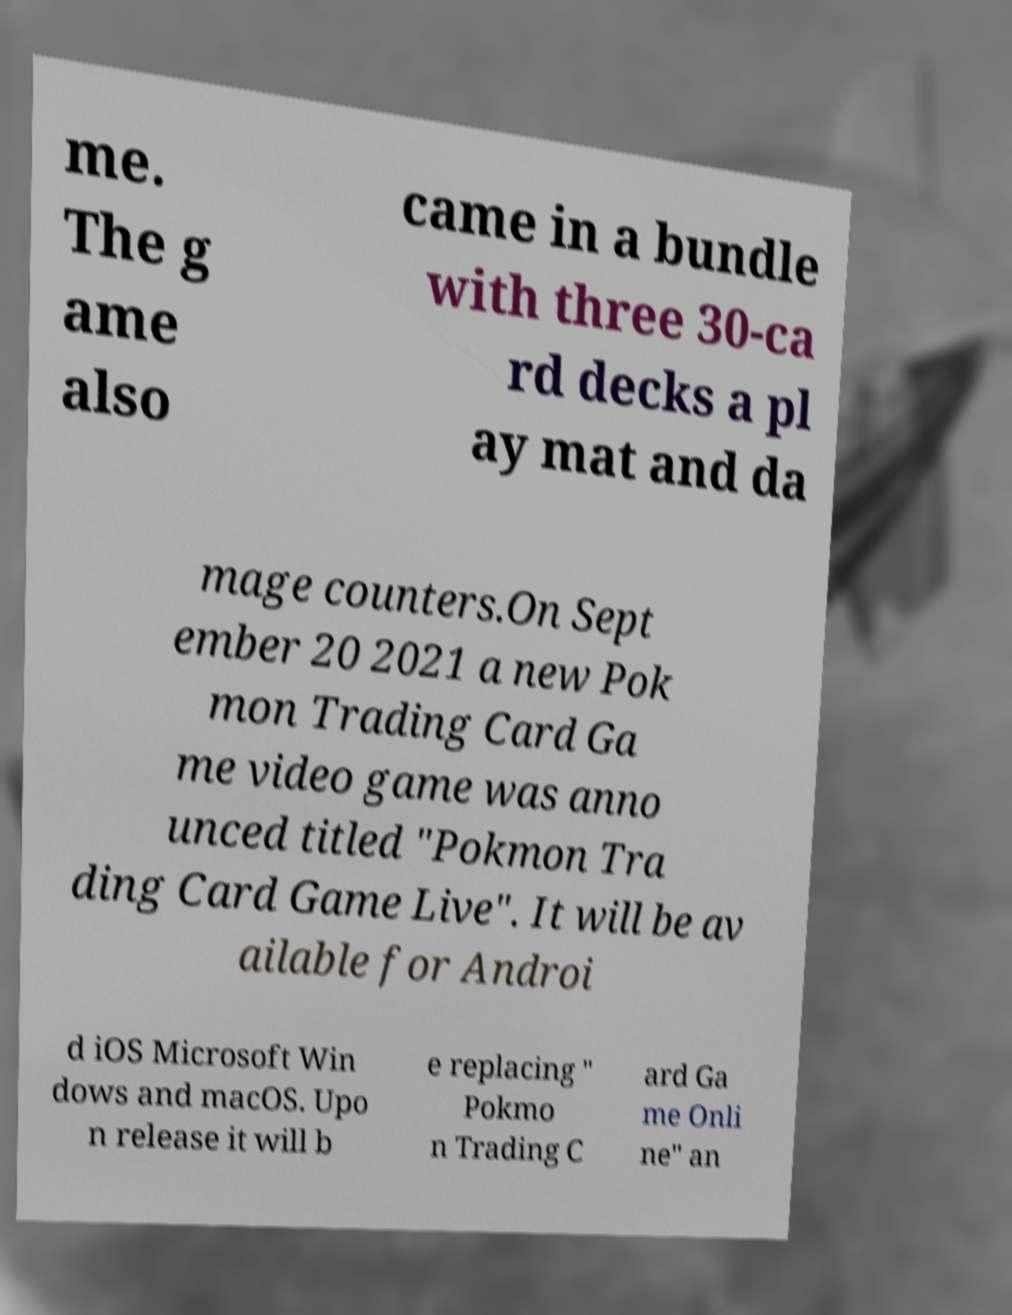Please identify and transcribe the text found in this image. me. The g ame also came in a bundle with three 30-ca rd decks a pl ay mat and da mage counters.On Sept ember 20 2021 a new Pok mon Trading Card Ga me video game was anno unced titled "Pokmon Tra ding Card Game Live". It will be av ailable for Androi d iOS Microsoft Win dows and macOS. Upo n release it will b e replacing " Pokmo n Trading C ard Ga me Onli ne" an 